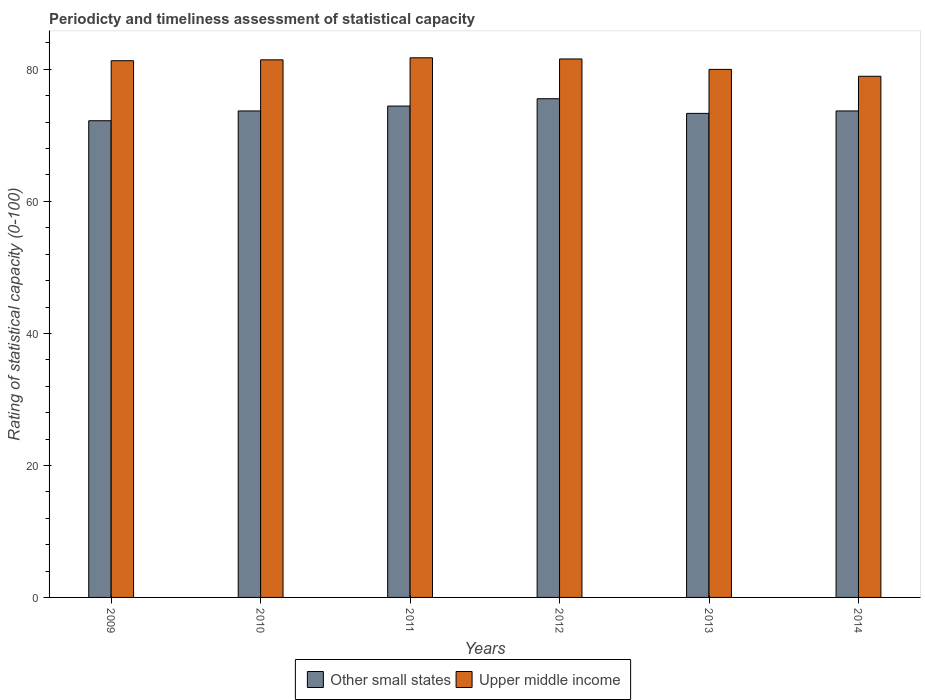Are the number of bars on each tick of the X-axis equal?
Make the answer very short. Yes. How many bars are there on the 1st tick from the left?
Provide a succinct answer. 2. What is the rating of statistical capacity in Other small states in 2013?
Offer a very short reply. 73.33. Across all years, what is the maximum rating of statistical capacity in Other small states?
Provide a short and direct response. 75.56. Across all years, what is the minimum rating of statistical capacity in Other small states?
Ensure brevity in your answer.  72.22. In which year was the rating of statistical capacity in Upper middle income maximum?
Ensure brevity in your answer.  2011. What is the total rating of statistical capacity in Upper middle income in the graph?
Provide a short and direct response. 485.05. What is the difference between the rating of statistical capacity in Upper middle income in 2010 and that in 2013?
Provide a succinct answer. 1.45. What is the difference between the rating of statistical capacity in Other small states in 2011 and the rating of statistical capacity in Upper middle income in 2014?
Offer a very short reply. -4.51. What is the average rating of statistical capacity in Other small states per year?
Offer a terse response. 73.83. In the year 2009, what is the difference between the rating of statistical capacity in Upper middle income and rating of statistical capacity in Other small states?
Offer a terse response. 9.09. What is the ratio of the rating of statistical capacity in Upper middle income in 2012 to that in 2014?
Provide a succinct answer. 1.03. What is the difference between the highest and the second highest rating of statistical capacity in Upper middle income?
Make the answer very short. 0.18. What is the difference between the highest and the lowest rating of statistical capacity in Other small states?
Keep it short and to the point. 3.33. Is the sum of the rating of statistical capacity in Upper middle income in 2010 and 2013 greater than the maximum rating of statistical capacity in Other small states across all years?
Your answer should be compact. Yes. What does the 1st bar from the left in 2009 represents?
Offer a terse response. Other small states. What does the 1st bar from the right in 2011 represents?
Keep it short and to the point. Upper middle income. Are all the bars in the graph horizontal?
Offer a terse response. No. How many years are there in the graph?
Provide a short and direct response. 6. What is the difference between two consecutive major ticks on the Y-axis?
Provide a short and direct response. 20. Does the graph contain any zero values?
Your answer should be compact. No. Where does the legend appear in the graph?
Provide a succinct answer. Bottom center. How many legend labels are there?
Make the answer very short. 2. What is the title of the graph?
Make the answer very short. Periodicty and timeliness assessment of statistical capacity. What is the label or title of the X-axis?
Give a very brief answer. Years. What is the label or title of the Y-axis?
Offer a terse response. Rating of statistical capacity (0-100). What is the Rating of statistical capacity (0-100) of Other small states in 2009?
Offer a terse response. 72.22. What is the Rating of statistical capacity (0-100) of Upper middle income in 2009?
Your answer should be very brief. 81.32. What is the Rating of statistical capacity (0-100) of Other small states in 2010?
Your response must be concise. 73.7. What is the Rating of statistical capacity (0-100) in Upper middle income in 2010?
Your response must be concise. 81.45. What is the Rating of statistical capacity (0-100) in Other small states in 2011?
Provide a succinct answer. 74.44. What is the Rating of statistical capacity (0-100) in Upper middle income in 2011?
Give a very brief answer. 81.75. What is the Rating of statistical capacity (0-100) in Other small states in 2012?
Make the answer very short. 75.56. What is the Rating of statistical capacity (0-100) in Upper middle income in 2012?
Keep it short and to the point. 81.58. What is the Rating of statistical capacity (0-100) of Other small states in 2013?
Keep it short and to the point. 73.33. What is the Rating of statistical capacity (0-100) of Other small states in 2014?
Make the answer very short. 73.7. What is the Rating of statistical capacity (0-100) in Upper middle income in 2014?
Your answer should be compact. 78.96. Across all years, what is the maximum Rating of statistical capacity (0-100) in Other small states?
Make the answer very short. 75.56. Across all years, what is the maximum Rating of statistical capacity (0-100) of Upper middle income?
Make the answer very short. 81.75. Across all years, what is the minimum Rating of statistical capacity (0-100) in Other small states?
Give a very brief answer. 72.22. Across all years, what is the minimum Rating of statistical capacity (0-100) of Upper middle income?
Give a very brief answer. 78.96. What is the total Rating of statistical capacity (0-100) of Other small states in the graph?
Make the answer very short. 442.96. What is the total Rating of statistical capacity (0-100) of Upper middle income in the graph?
Your answer should be very brief. 485.05. What is the difference between the Rating of statistical capacity (0-100) in Other small states in 2009 and that in 2010?
Ensure brevity in your answer.  -1.48. What is the difference between the Rating of statistical capacity (0-100) in Upper middle income in 2009 and that in 2010?
Your answer should be very brief. -0.13. What is the difference between the Rating of statistical capacity (0-100) of Other small states in 2009 and that in 2011?
Offer a terse response. -2.22. What is the difference between the Rating of statistical capacity (0-100) of Upper middle income in 2009 and that in 2011?
Offer a terse response. -0.44. What is the difference between the Rating of statistical capacity (0-100) of Other small states in 2009 and that in 2012?
Your response must be concise. -3.33. What is the difference between the Rating of statistical capacity (0-100) in Upper middle income in 2009 and that in 2012?
Offer a very short reply. -0.26. What is the difference between the Rating of statistical capacity (0-100) of Other small states in 2009 and that in 2013?
Offer a very short reply. -1.11. What is the difference between the Rating of statistical capacity (0-100) in Upper middle income in 2009 and that in 2013?
Offer a terse response. 1.32. What is the difference between the Rating of statistical capacity (0-100) in Other small states in 2009 and that in 2014?
Your answer should be compact. -1.48. What is the difference between the Rating of statistical capacity (0-100) in Upper middle income in 2009 and that in 2014?
Give a very brief answer. 2.36. What is the difference between the Rating of statistical capacity (0-100) in Other small states in 2010 and that in 2011?
Ensure brevity in your answer.  -0.74. What is the difference between the Rating of statistical capacity (0-100) of Upper middle income in 2010 and that in 2011?
Your response must be concise. -0.31. What is the difference between the Rating of statistical capacity (0-100) in Other small states in 2010 and that in 2012?
Offer a very short reply. -1.85. What is the difference between the Rating of statistical capacity (0-100) of Upper middle income in 2010 and that in 2012?
Provide a short and direct response. -0.13. What is the difference between the Rating of statistical capacity (0-100) in Other small states in 2010 and that in 2013?
Provide a short and direct response. 0.37. What is the difference between the Rating of statistical capacity (0-100) in Upper middle income in 2010 and that in 2013?
Offer a terse response. 1.45. What is the difference between the Rating of statistical capacity (0-100) of Upper middle income in 2010 and that in 2014?
Your answer should be compact. 2.49. What is the difference between the Rating of statistical capacity (0-100) in Other small states in 2011 and that in 2012?
Your answer should be very brief. -1.11. What is the difference between the Rating of statistical capacity (0-100) in Upper middle income in 2011 and that in 2012?
Provide a short and direct response. 0.18. What is the difference between the Rating of statistical capacity (0-100) in Upper middle income in 2011 and that in 2013?
Your answer should be compact. 1.75. What is the difference between the Rating of statistical capacity (0-100) in Other small states in 2011 and that in 2014?
Give a very brief answer. 0.74. What is the difference between the Rating of statistical capacity (0-100) in Upper middle income in 2011 and that in 2014?
Provide a succinct answer. 2.8. What is the difference between the Rating of statistical capacity (0-100) in Other small states in 2012 and that in 2013?
Ensure brevity in your answer.  2.22. What is the difference between the Rating of statistical capacity (0-100) of Upper middle income in 2012 and that in 2013?
Provide a short and direct response. 1.58. What is the difference between the Rating of statistical capacity (0-100) of Other small states in 2012 and that in 2014?
Ensure brevity in your answer.  1.85. What is the difference between the Rating of statistical capacity (0-100) in Upper middle income in 2012 and that in 2014?
Offer a very short reply. 2.62. What is the difference between the Rating of statistical capacity (0-100) in Other small states in 2013 and that in 2014?
Your answer should be very brief. -0.37. What is the difference between the Rating of statistical capacity (0-100) in Upper middle income in 2013 and that in 2014?
Your response must be concise. 1.04. What is the difference between the Rating of statistical capacity (0-100) of Other small states in 2009 and the Rating of statistical capacity (0-100) of Upper middle income in 2010?
Your answer should be compact. -9.22. What is the difference between the Rating of statistical capacity (0-100) of Other small states in 2009 and the Rating of statistical capacity (0-100) of Upper middle income in 2011?
Make the answer very short. -9.53. What is the difference between the Rating of statistical capacity (0-100) in Other small states in 2009 and the Rating of statistical capacity (0-100) in Upper middle income in 2012?
Your answer should be very brief. -9.36. What is the difference between the Rating of statistical capacity (0-100) of Other small states in 2009 and the Rating of statistical capacity (0-100) of Upper middle income in 2013?
Provide a short and direct response. -7.78. What is the difference between the Rating of statistical capacity (0-100) in Other small states in 2009 and the Rating of statistical capacity (0-100) in Upper middle income in 2014?
Make the answer very short. -6.73. What is the difference between the Rating of statistical capacity (0-100) of Other small states in 2010 and the Rating of statistical capacity (0-100) of Upper middle income in 2011?
Your answer should be very brief. -8.05. What is the difference between the Rating of statistical capacity (0-100) of Other small states in 2010 and the Rating of statistical capacity (0-100) of Upper middle income in 2012?
Ensure brevity in your answer.  -7.88. What is the difference between the Rating of statistical capacity (0-100) of Other small states in 2010 and the Rating of statistical capacity (0-100) of Upper middle income in 2013?
Offer a terse response. -6.3. What is the difference between the Rating of statistical capacity (0-100) in Other small states in 2010 and the Rating of statistical capacity (0-100) in Upper middle income in 2014?
Provide a succinct answer. -5.25. What is the difference between the Rating of statistical capacity (0-100) of Other small states in 2011 and the Rating of statistical capacity (0-100) of Upper middle income in 2012?
Your answer should be compact. -7.13. What is the difference between the Rating of statistical capacity (0-100) in Other small states in 2011 and the Rating of statistical capacity (0-100) in Upper middle income in 2013?
Your response must be concise. -5.56. What is the difference between the Rating of statistical capacity (0-100) of Other small states in 2011 and the Rating of statistical capacity (0-100) of Upper middle income in 2014?
Your answer should be very brief. -4.51. What is the difference between the Rating of statistical capacity (0-100) in Other small states in 2012 and the Rating of statistical capacity (0-100) in Upper middle income in 2013?
Your response must be concise. -4.44. What is the difference between the Rating of statistical capacity (0-100) in Other small states in 2012 and the Rating of statistical capacity (0-100) in Upper middle income in 2014?
Your response must be concise. -3.4. What is the difference between the Rating of statistical capacity (0-100) of Other small states in 2013 and the Rating of statistical capacity (0-100) of Upper middle income in 2014?
Give a very brief answer. -5.62. What is the average Rating of statistical capacity (0-100) of Other small states per year?
Offer a terse response. 73.83. What is the average Rating of statistical capacity (0-100) in Upper middle income per year?
Offer a terse response. 80.84. In the year 2009, what is the difference between the Rating of statistical capacity (0-100) in Other small states and Rating of statistical capacity (0-100) in Upper middle income?
Your answer should be compact. -9.09. In the year 2010, what is the difference between the Rating of statistical capacity (0-100) of Other small states and Rating of statistical capacity (0-100) of Upper middle income?
Offer a very short reply. -7.74. In the year 2011, what is the difference between the Rating of statistical capacity (0-100) in Other small states and Rating of statistical capacity (0-100) in Upper middle income?
Your answer should be very brief. -7.31. In the year 2012, what is the difference between the Rating of statistical capacity (0-100) of Other small states and Rating of statistical capacity (0-100) of Upper middle income?
Provide a short and direct response. -6.02. In the year 2013, what is the difference between the Rating of statistical capacity (0-100) in Other small states and Rating of statistical capacity (0-100) in Upper middle income?
Provide a short and direct response. -6.67. In the year 2014, what is the difference between the Rating of statistical capacity (0-100) of Other small states and Rating of statistical capacity (0-100) of Upper middle income?
Your answer should be compact. -5.25. What is the ratio of the Rating of statistical capacity (0-100) of Other small states in 2009 to that in 2010?
Provide a short and direct response. 0.98. What is the ratio of the Rating of statistical capacity (0-100) in Upper middle income in 2009 to that in 2010?
Keep it short and to the point. 1. What is the ratio of the Rating of statistical capacity (0-100) of Other small states in 2009 to that in 2011?
Make the answer very short. 0.97. What is the ratio of the Rating of statistical capacity (0-100) in Other small states in 2009 to that in 2012?
Offer a terse response. 0.96. What is the ratio of the Rating of statistical capacity (0-100) of Upper middle income in 2009 to that in 2012?
Your answer should be compact. 1. What is the ratio of the Rating of statistical capacity (0-100) of Other small states in 2009 to that in 2013?
Give a very brief answer. 0.98. What is the ratio of the Rating of statistical capacity (0-100) in Upper middle income in 2009 to that in 2013?
Your answer should be very brief. 1.02. What is the ratio of the Rating of statistical capacity (0-100) of Other small states in 2009 to that in 2014?
Provide a short and direct response. 0.98. What is the ratio of the Rating of statistical capacity (0-100) in Upper middle income in 2009 to that in 2014?
Provide a short and direct response. 1.03. What is the ratio of the Rating of statistical capacity (0-100) in Upper middle income in 2010 to that in 2011?
Provide a succinct answer. 1. What is the ratio of the Rating of statistical capacity (0-100) in Other small states in 2010 to that in 2012?
Provide a short and direct response. 0.98. What is the ratio of the Rating of statistical capacity (0-100) in Upper middle income in 2010 to that in 2013?
Make the answer very short. 1.02. What is the ratio of the Rating of statistical capacity (0-100) of Upper middle income in 2010 to that in 2014?
Offer a terse response. 1.03. What is the ratio of the Rating of statistical capacity (0-100) in Other small states in 2011 to that in 2013?
Make the answer very short. 1.02. What is the ratio of the Rating of statistical capacity (0-100) in Upper middle income in 2011 to that in 2013?
Your answer should be compact. 1.02. What is the ratio of the Rating of statistical capacity (0-100) of Upper middle income in 2011 to that in 2014?
Provide a succinct answer. 1.04. What is the ratio of the Rating of statistical capacity (0-100) of Other small states in 2012 to that in 2013?
Offer a very short reply. 1.03. What is the ratio of the Rating of statistical capacity (0-100) in Upper middle income in 2012 to that in 2013?
Give a very brief answer. 1.02. What is the ratio of the Rating of statistical capacity (0-100) of Other small states in 2012 to that in 2014?
Provide a succinct answer. 1.03. What is the ratio of the Rating of statistical capacity (0-100) of Upper middle income in 2012 to that in 2014?
Make the answer very short. 1.03. What is the ratio of the Rating of statistical capacity (0-100) of Other small states in 2013 to that in 2014?
Offer a terse response. 0.99. What is the ratio of the Rating of statistical capacity (0-100) of Upper middle income in 2013 to that in 2014?
Offer a very short reply. 1.01. What is the difference between the highest and the second highest Rating of statistical capacity (0-100) in Other small states?
Your response must be concise. 1.11. What is the difference between the highest and the second highest Rating of statistical capacity (0-100) of Upper middle income?
Your response must be concise. 0.18. What is the difference between the highest and the lowest Rating of statistical capacity (0-100) in Upper middle income?
Keep it short and to the point. 2.8. 